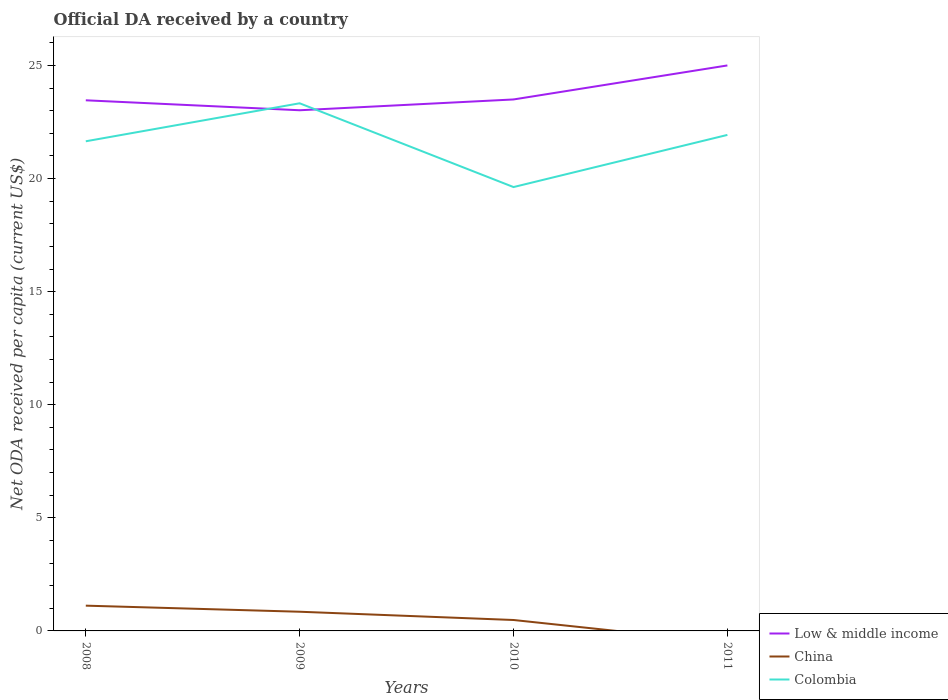Is the number of lines equal to the number of legend labels?
Provide a short and direct response. No. Across all years, what is the maximum ODA received in in Colombia?
Keep it short and to the point. 19.62. What is the total ODA received in in Low & middle income in the graph?
Give a very brief answer. -1.5. What is the difference between the highest and the second highest ODA received in in Low & middle income?
Offer a terse response. 1.98. What is the difference between two consecutive major ticks on the Y-axis?
Your response must be concise. 5. Are the values on the major ticks of Y-axis written in scientific E-notation?
Offer a terse response. No. Does the graph contain grids?
Give a very brief answer. No. Where does the legend appear in the graph?
Provide a short and direct response. Bottom right. How many legend labels are there?
Your response must be concise. 3. How are the legend labels stacked?
Your answer should be very brief. Vertical. What is the title of the graph?
Your answer should be very brief. Official DA received by a country. What is the label or title of the Y-axis?
Your response must be concise. Net ODA received per capita (current US$). What is the Net ODA received per capita (current US$) in Low & middle income in 2008?
Make the answer very short. 23.46. What is the Net ODA received per capita (current US$) in China in 2008?
Your answer should be compact. 1.12. What is the Net ODA received per capita (current US$) in Colombia in 2008?
Provide a short and direct response. 21.65. What is the Net ODA received per capita (current US$) of Low & middle income in 2009?
Make the answer very short. 23.02. What is the Net ODA received per capita (current US$) in China in 2009?
Your answer should be very brief. 0.85. What is the Net ODA received per capita (current US$) of Colombia in 2009?
Your response must be concise. 23.33. What is the Net ODA received per capita (current US$) in Low & middle income in 2010?
Keep it short and to the point. 23.5. What is the Net ODA received per capita (current US$) in China in 2010?
Provide a succinct answer. 0.48. What is the Net ODA received per capita (current US$) of Colombia in 2010?
Provide a short and direct response. 19.62. What is the Net ODA received per capita (current US$) of Low & middle income in 2011?
Your answer should be very brief. 25. What is the Net ODA received per capita (current US$) in China in 2011?
Your answer should be very brief. 0. What is the Net ODA received per capita (current US$) of Colombia in 2011?
Provide a succinct answer. 21.93. Across all years, what is the maximum Net ODA received per capita (current US$) in Low & middle income?
Ensure brevity in your answer.  25. Across all years, what is the maximum Net ODA received per capita (current US$) in China?
Provide a short and direct response. 1.12. Across all years, what is the maximum Net ODA received per capita (current US$) of Colombia?
Your response must be concise. 23.33. Across all years, what is the minimum Net ODA received per capita (current US$) in Low & middle income?
Offer a terse response. 23.02. Across all years, what is the minimum Net ODA received per capita (current US$) in China?
Provide a succinct answer. 0. Across all years, what is the minimum Net ODA received per capita (current US$) of Colombia?
Provide a succinct answer. 19.62. What is the total Net ODA received per capita (current US$) in Low & middle income in the graph?
Offer a very short reply. 94.98. What is the total Net ODA received per capita (current US$) in China in the graph?
Provide a succinct answer. 2.45. What is the total Net ODA received per capita (current US$) of Colombia in the graph?
Provide a short and direct response. 86.53. What is the difference between the Net ODA received per capita (current US$) of Low & middle income in 2008 and that in 2009?
Keep it short and to the point. 0.44. What is the difference between the Net ODA received per capita (current US$) in China in 2008 and that in 2009?
Offer a terse response. 0.27. What is the difference between the Net ODA received per capita (current US$) in Colombia in 2008 and that in 2009?
Ensure brevity in your answer.  -1.68. What is the difference between the Net ODA received per capita (current US$) of Low & middle income in 2008 and that in 2010?
Provide a succinct answer. -0.04. What is the difference between the Net ODA received per capita (current US$) in China in 2008 and that in 2010?
Your response must be concise. 0.63. What is the difference between the Net ODA received per capita (current US$) of Colombia in 2008 and that in 2010?
Keep it short and to the point. 2.02. What is the difference between the Net ODA received per capita (current US$) in Low & middle income in 2008 and that in 2011?
Make the answer very short. -1.54. What is the difference between the Net ODA received per capita (current US$) of Colombia in 2008 and that in 2011?
Keep it short and to the point. -0.28. What is the difference between the Net ODA received per capita (current US$) in Low & middle income in 2009 and that in 2010?
Offer a terse response. -0.48. What is the difference between the Net ODA received per capita (current US$) in China in 2009 and that in 2010?
Your response must be concise. 0.37. What is the difference between the Net ODA received per capita (current US$) of Colombia in 2009 and that in 2010?
Your answer should be very brief. 3.7. What is the difference between the Net ODA received per capita (current US$) in Low & middle income in 2009 and that in 2011?
Your answer should be very brief. -1.98. What is the difference between the Net ODA received per capita (current US$) in Colombia in 2009 and that in 2011?
Provide a short and direct response. 1.4. What is the difference between the Net ODA received per capita (current US$) of Low & middle income in 2010 and that in 2011?
Your response must be concise. -1.5. What is the difference between the Net ODA received per capita (current US$) in Colombia in 2010 and that in 2011?
Provide a short and direct response. -2.31. What is the difference between the Net ODA received per capita (current US$) in Low & middle income in 2008 and the Net ODA received per capita (current US$) in China in 2009?
Provide a succinct answer. 22.61. What is the difference between the Net ODA received per capita (current US$) of Low & middle income in 2008 and the Net ODA received per capita (current US$) of Colombia in 2009?
Provide a short and direct response. 0.13. What is the difference between the Net ODA received per capita (current US$) in China in 2008 and the Net ODA received per capita (current US$) in Colombia in 2009?
Offer a terse response. -22.21. What is the difference between the Net ODA received per capita (current US$) of Low & middle income in 2008 and the Net ODA received per capita (current US$) of China in 2010?
Make the answer very short. 22.98. What is the difference between the Net ODA received per capita (current US$) of Low & middle income in 2008 and the Net ODA received per capita (current US$) of Colombia in 2010?
Provide a short and direct response. 3.84. What is the difference between the Net ODA received per capita (current US$) in China in 2008 and the Net ODA received per capita (current US$) in Colombia in 2010?
Offer a very short reply. -18.51. What is the difference between the Net ODA received per capita (current US$) of Low & middle income in 2008 and the Net ODA received per capita (current US$) of Colombia in 2011?
Your response must be concise. 1.53. What is the difference between the Net ODA received per capita (current US$) in China in 2008 and the Net ODA received per capita (current US$) in Colombia in 2011?
Ensure brevity in your answer.  -20.81. What is the difference between the Net ODA received per capita (current US$) of Low & middle income in 2009 and the Net ODA received per capita (current US$) of China in 2010?
Your answer should be compact. 22.54. What is the difference between the Net ODA received per capita (current US$) in Low & middle income in 2009 and the Net ODA received per capita (current US$) in Colombia in 2010?
Offer a terse response. 3.4. What is the difference between the Net ODA received per capita (current US$) in China in 2009 and the Net ODA received per capita (current US$) in Colombia in 2010?
Offer a very short reply. -18.78. What is the difference between the Net ODA received per capita (current US$) of Low & middle income in 2009 and the Net ODA received per capita (current US$) of Colombia in 2011?
Provide a succinct answer. 1.09. What is the difference between the Net ODA received per capita (current US$) of China in 2009 and the Net ODA received per capita (current US$) of Colombia in 2011?
Offer a very short reply. -21.08. What is the difference between the Net ODA received per capita (current US$) of Low & middle income in 2010 and the Net ODA received per capita (current US$) of Colombia in 2011?
Your response must be concise. 1.57. What is the difference between the Net ODA received per capita (current US$) in China in 2010 and the Net ODA received per capita (current US$) in Colombia in 2011?
Make the answer very short. -21.45. What is the average Net ODA received per capita (current US$) in Low & middle income per year?
Offer a terse response. 23.74. What is the average Net ODA received per capita (current US$) of China per year?
Your answer should be compact. 0.61. What is the average Net ODA received per capita (current US$) in Colombia per year?
Keep it short and to the point. 21.63. In the year 2008, what is the difference between the Net ODA received per capita (current US$) of Low & middle income and Net ODA received per capita (current US$) of China?
Provide a succinct answer. 22.34. In the year 2008, what is the difference between the Net ODA received per capita (current US$) of Low & middle income and Net ODA received per capita (current US$) of Colombia?
Your response must be concise. 1.81. In the year 2008, what is the difference between the Net ODA received per capita (current US$) of China and Net ODA received per capita (current US$) of Colombia?
Your answer should be very brief. -20.53. In the year 2009, what is the difference between the Net ODA received per capita (current US$) in Low & middle income and Net ODA received per capita (current US$) in China?
Your answer should be compact. 22.17. In the year 2009, what is the difference between the Net ODA received per capita (current US$) of Low & middle income and Net ODA received per capita (current US$) of Colombia?
Your answer should be compact. -0.31. In the year 2009, what is the difference between the Net ODA received per capita (current US$) in China and Net ODA received per capita (current US$) in Colombia?
Ensure brevity in your answer.  -22.48. In the year 2010, what is the difference between the Net ODA received per capita (current US$) of Low & middle income and Net ODA received per capita (current US$) of China?
Your answer should be compact. 23.01. In the year 2010, what is the difference between the Net ODA received per capita (current US$) of Low & middle income and Net ODA received per capita (current US$) of Colombia?
Keep it short and to the point. 3.87. In the year 2010, what is the difference between the Net ODA received per capita (current US$) in China and Net ODA received per capita (current US$) in Colombia?
Your answer should be very brief. -19.14. In the year 2011, what is the difference between the Net ODA received per capita (current US$) in Low & middle income and Net ODA received per capita (current US$) in Colombia?
Ensure brevity in your answer.  3.07. What is the ratio of the Net ODA received per capita (current US$) in Low & middle income in 2008 to that in 2009?
Keep it short and to the point. 1.02. What is the ratio of the Net ODA received per capita (current US$) of China in 2008 to that in 2009?
Ensure brevity in your answer.  1.32. What is the ratio of the Net ODA received per capita (current US$) of Colombia in 2008 to that in 2009?
Give a very brief answer. 0.93. What is the ratio of the Net ODA received per capita (current US$) of China in 2008 to that in 2010?
Keep it short and to the point. 2.31. What is the ratio of the Net ODA received per capita (current US$) of Colombia in 2008 to that in 2010?
Make the answer very short. 1.1. What is the ratio of the Net ODA received per capita (current US$) in Low & middle income in 2008 to that in 2011?
Your answer should be compact. 0.94. What is the ratio of the Net ODA received per capita (current US$) in Colombia in 2008 to that in 2011?
Give a very brief answer. 0.99. What is the ratio of the Net ODA received per capita (current US$) of Low & middle income in 2009 to that in 2010?
Make the answer very short. 0.98. What is the ratio of the Net ODA received per capita (current US$) of China in 2009 to that in 2010?
Offer a very short reply. 1.76. What is the ratio of the Net ODA received per capita (current US$) in Colombia in 2009 to that in 2010?
Provide a succinct answer. 1.19. What is the ratio of the Net ODA received per capita (current US$) in Low & middle income in 2009 to that in 2011?
Offer a terse response. 0.92. What is the ratio of the Net ODA received per capita (current US$) of Colombia in 2009 to that in 2011?
Your response must be concise. 1.06. What is the ratio of the Net ODA received per capita (current US$) in Low & middle income in 2010 to that in 2011?
Your answer should be compact. 0.94. What is the ratio of the Net ODA received per capita (current US$) in Colombia in 2010 to that in 2011?
Offer a terse response. 0.89. What is the difference between the highest and the second highest Net ODA received per capita (current US$) of Low & middle income?
Offer a terse response. 1.5. What is the difference between the highest and the second highest Net ODA received per capita (current US$) in China?
Offer a terse response. 0.27. What is the difference between the highest and the second highest Net ODA received per capita (current US$) in Colombia?
Offer a terse response. 1.4. What is the difference between the highest and the lowest Net ODA received per capita (current US$) of Low & middle income?
Your response must be concise. 1.98. What is the difference between the highest and the lowest Net ODA received per capita (current US$) in China?
Offer a very short reply. 1.12. What is the difference between the highest and the lowest Net ODA received per capita (current US$) in Colombia?
Keep it short and to the point. 3.7. 